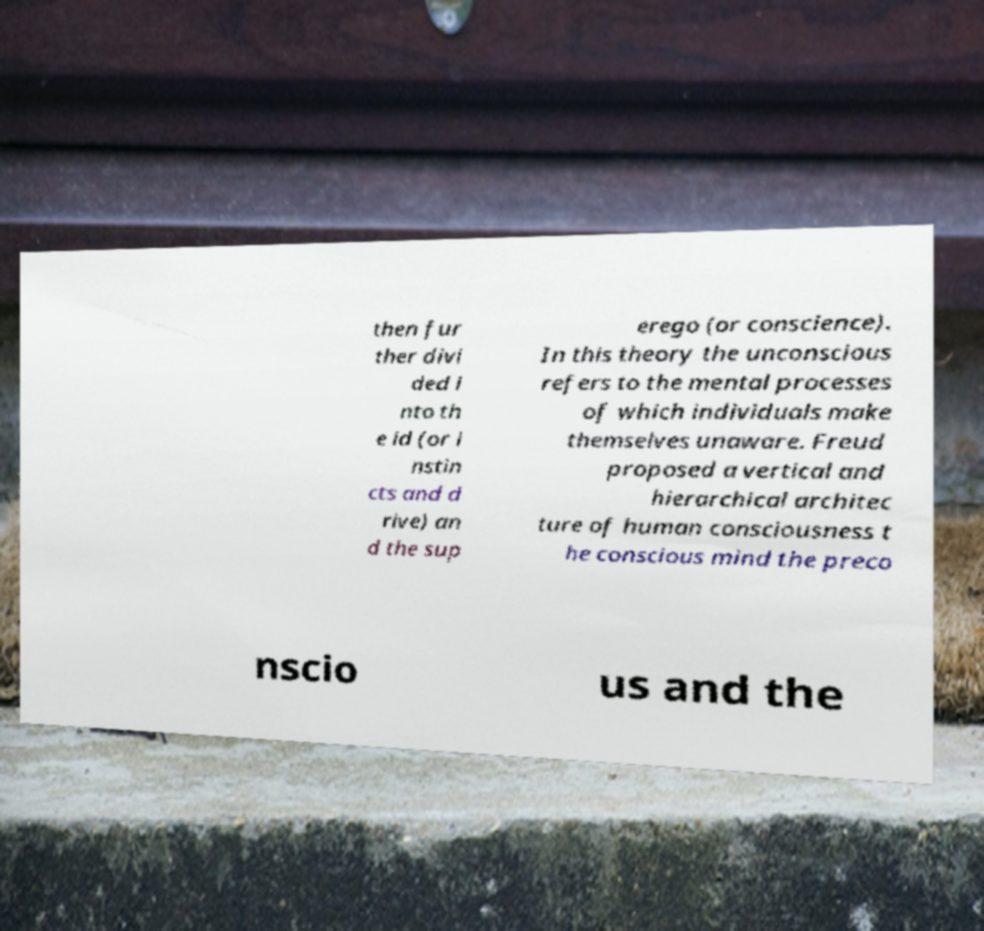What messages or text are displayed in this image? I need them in a readable, typed format. then fur ther divi ded i nto th e id (or i nstin cts and d rive) an d the sup erego (or conscience). In this theory the unconscious refers to the mental processes of which individuals make themselves unaware. Freud proposed a vertical and hierarchical architec ture of human consciousness t he conscious mind the preco nscio us and the 